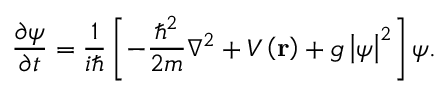Convert formula to latex. <formula><loc_0><loc_0><loc_500><loc_500>\frac { \partial \psi } { \partial t } = \frac { 1 } { i } \left [ - \frac { \hbar { ^ } { 2 } } { 2 m } \nabla ^ { 2 } + V \left ( r \right ) + g \left | \psi \right | ^ { 2 } \right ] \psi .</formula> 